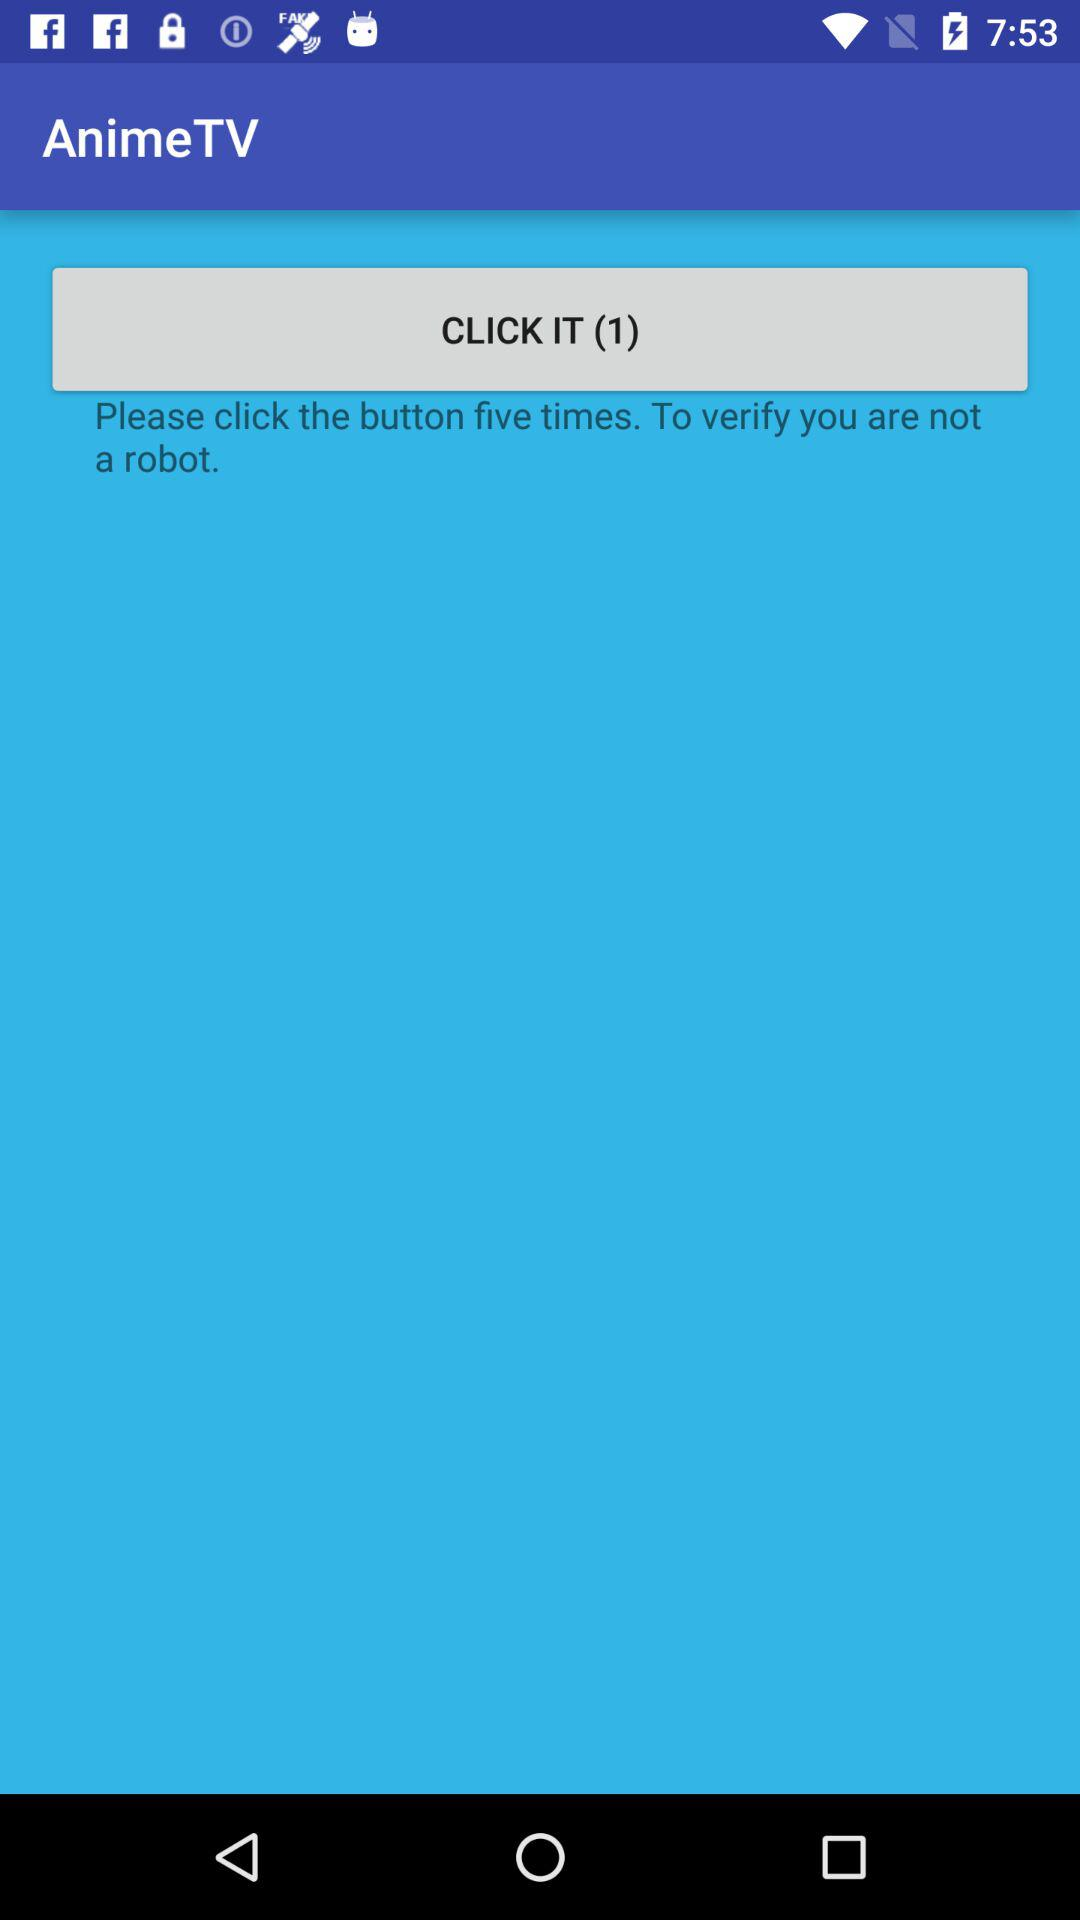What is the name of the application? The name of the application is "AnimeTV". 